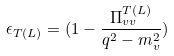Convert formula to latex. <formula><loc_0><loc_0><loc_500><loc_500>\epsilon _ { T ( L ) } = ( 1 - \frac { \Pi ^ { T ( L ) } _ { v v } } { q ^ { 2 } - m _ { v } ^ { 2 } } )</formula> 